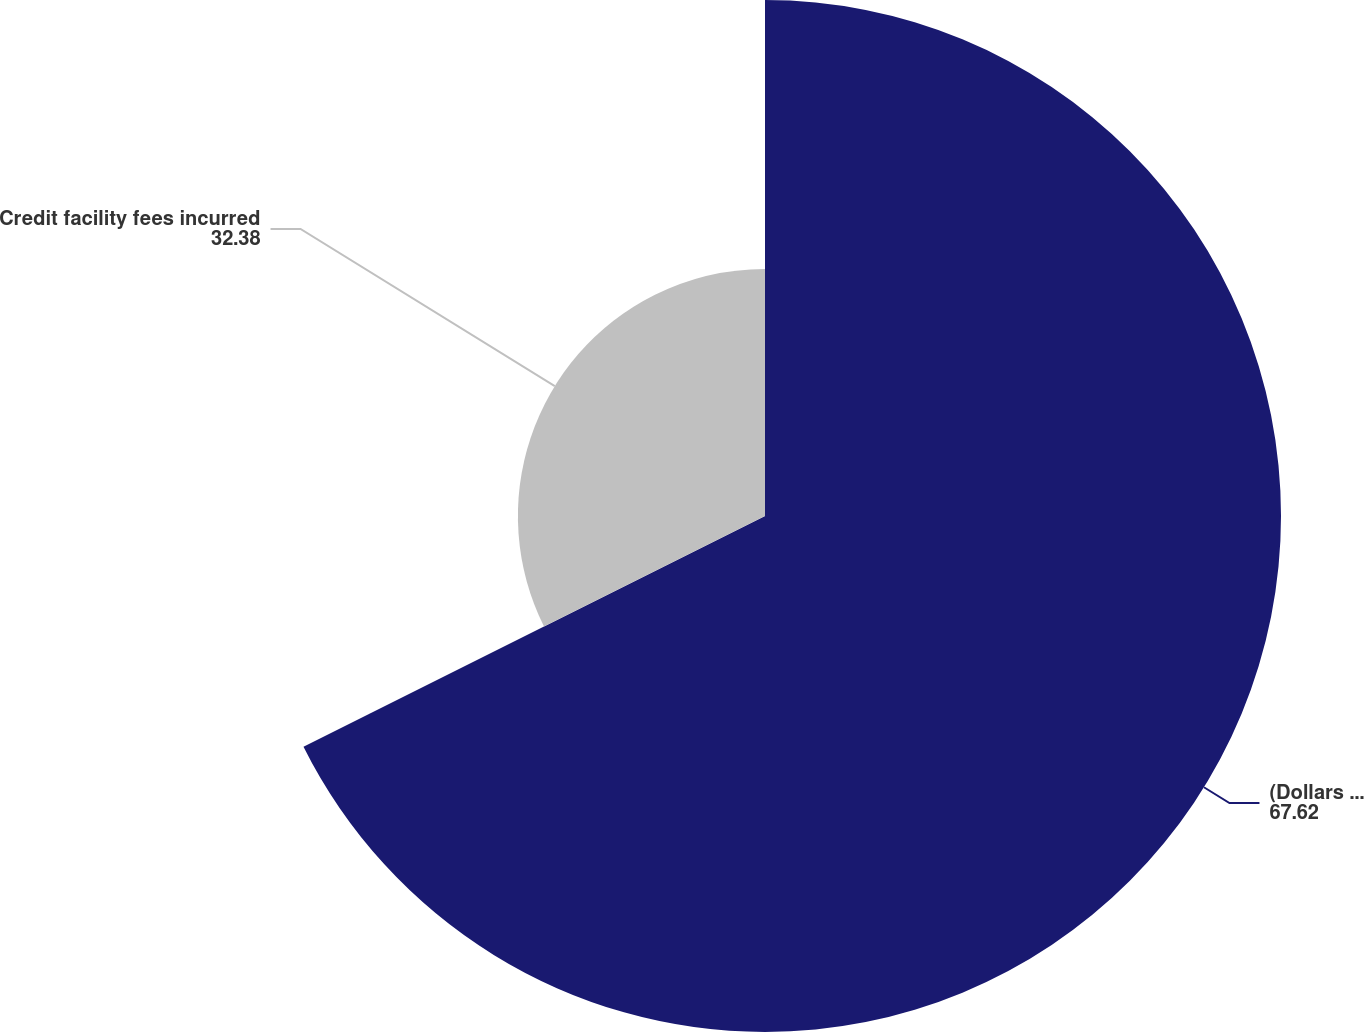Convert chart. <chart><loc_0><loc_0><loc_500><loc_500><pie_chart><fcel>(Dollars in thousands)<fcel>Credit facility fees incurred<nl><fcel>67.62%<fcel>32.38%<nl></chart> 